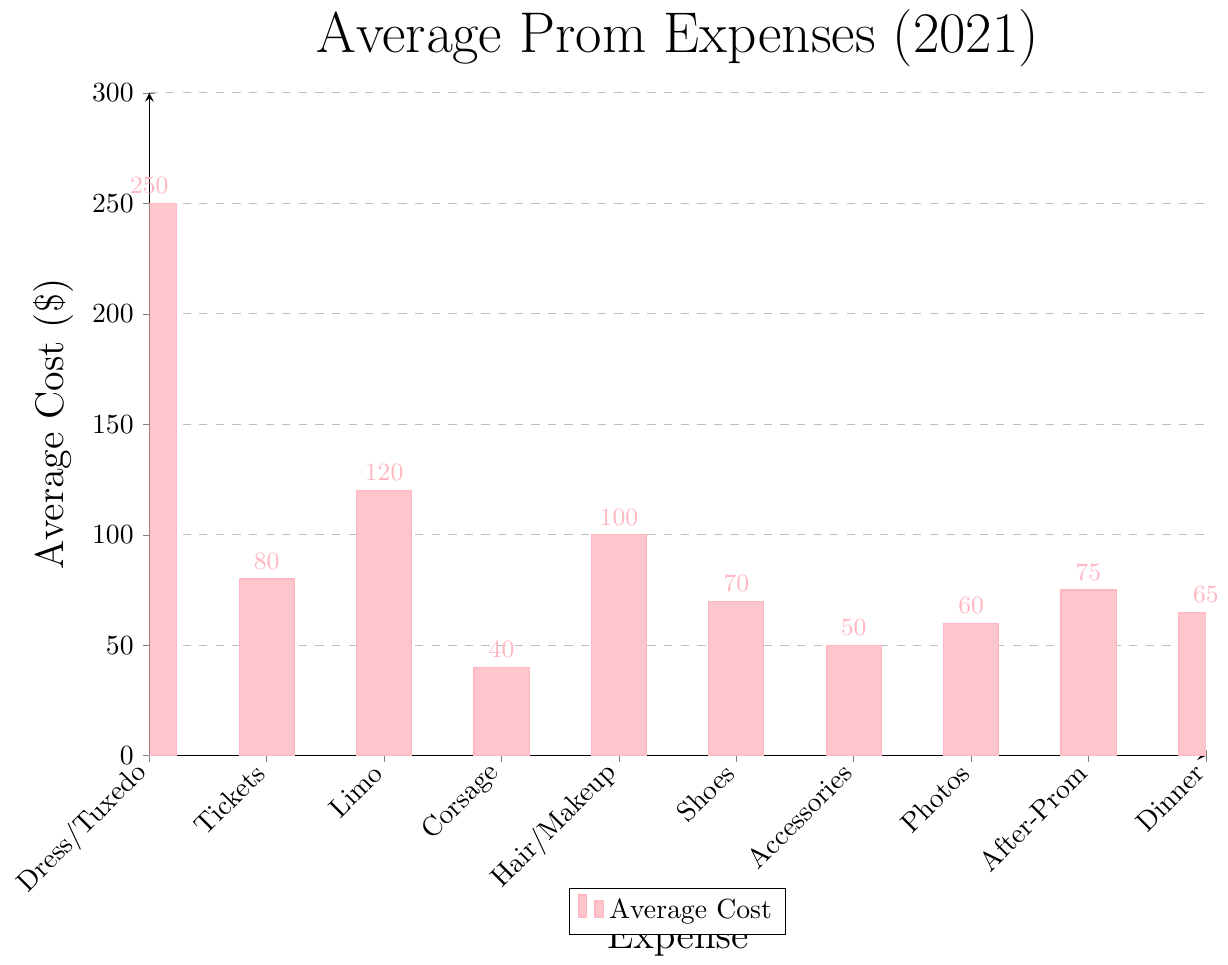What is the most expensive prom expense? The height of the bar representing Dress/Tuxedo is the tallest in the chart, which corresponds to $250.
Answer: Dress/Tuxedo Which expenses cost less than $100? The bars representing Tickets, Corsage/Boutonniere, Shoes, Accessories, Professional Photos, After-Prom Activities, and Dinner are all shorter than the $100 mark on the y-axis.
Answer: Tickets, Corsage/Boutonniere, Shoes, Accessories, Professional Photos, After-Prom Activities, Dinner How much more expensive is the transportation (limo) compared to professional photos? The cost of transportation (limo) is $120 and the cost of professional photos is $60. Subtracting the two gives $120 - $60.
Answer: $60 What is the total cost of attire-related expenses (Dress/Tuxedo, Shoes, Accessories)? The costs of Dress/Tuxedo, Shoes, and Accessories are $250, $70, and $50 respectively. Adding these together gives $250 + $70 + $50.
Answer: $370 If you only spend money on tickets, dinner, and after-prom activities, what would be the total expenditure? The costs are $80 for tickets, $65 for dinner, and $75 for after-prom activities. Summing these amounts gives $80 + $65 + $75.
Answer: $220 Which category has a cost equal to the median value of all expenses listed? Listing the expenses in ascending order: $40, $50, $60, $65, $70, $75, $80, $100, $120, $250, we find the median is the middle value of the sorted list. With 10 values, the median is the average of the 5th and 6th values: ($70 + $75) / 2 = $72.5. None of the expenses are exactly $72.5.
Answer: None Is the average cost of hair and makeup greater than the average cost of after-prom activities and dinner combined? The cost for hair and makeup is $100. The combined cost of after-prom activities and dinner is $75 + $65 = $140. Since $100 is less than $140, the average cost of hair and makeup is not greater.
Answer: No How much do tickets and transportation together contribute to the total prom expenses? Adding the costs of tickets ($80) and transportation ($120) gives $80 + $120.
Answer: $200 Which expenses are represented by bars with similar heights and what are their costs? The bars representing professional photos ($60), dinner ($65), and after-prom activities ($75) have similar heights, indicating similar costs.
Answer: Professional photos ($60), dinner ($65), after-prom activities ($75) What is the difference between the most and least expensive prom expenses? The most expensive is Dress/Tuxedo at $250, and the least expensive is Corsage/Boutonniere at $40. Subtracting the least from the most gives $250 - $40.
Answer: $210 